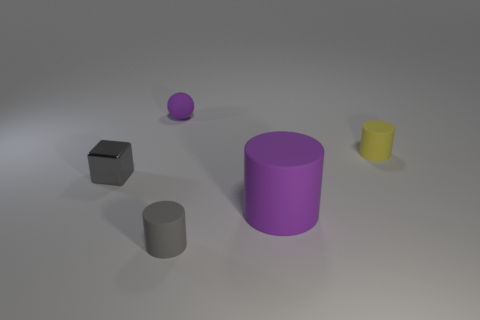Add 4 large brown matte balls. How many objects exist? 9 Subtract all spheres. How many objects are left? 4 Subtract 0 brown cubes. How many objects are left? 5 Subtract all purple things. Subtract all small blocks. How many objects are left? 2 Add 3 small metal cubes. How many small metal cubes are left? 4 Add 2 small gray shiny things. How many small gray shiny things exist? 3 